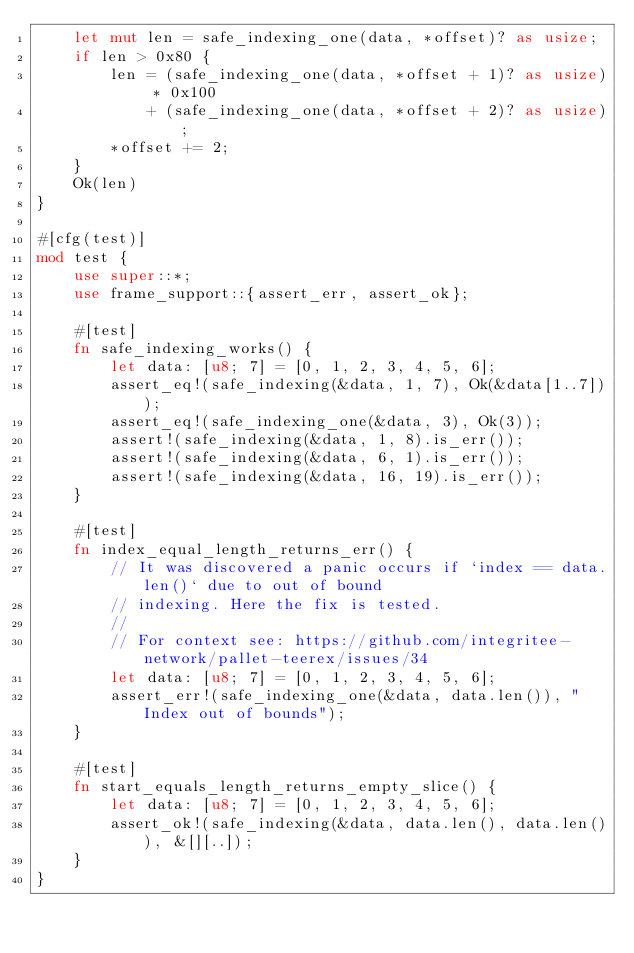<code> <loc_0><loc_0><loc_500><loc_500><_Rust_>    let mut len = safe_indexing_one(data, *offset)? as usize;
    if len > 0x80 {
        len = (safe_indexing_one(data, *offset + 1)? as usize) * 0x100
            + (safe_indexing_one(data, *offset + 2)? as usize);
        *offset += 2;
    }
    Ok(len)
}

#[cfg(test)]
mod test {
    use super::*;
    use frame_support::{assert_err, assert_ok};

    #[test]
    fn safe_indexing_works() {
        let data: [u8; 7] = [0, 1, 2, 3, 4, 5, 6];
        assert_eq!(safe_indexing(&data, 1, 7), Ok(&data[1..7]));
        assert_eq!(safe_indexing_one(&data, 3), Ok(3));
        assert!(safe_indexing(&data, 1, 8).is_err());
        assert!(safe_indexing(&data, 6, 1).is_err());
        assert!(safe_indexing(&data, 16, 19).is_err());
    }

    #[test]
    fn index_equal_length_returns_err() {
        // It was discovered a panic occurs if `index == data.len()` due to out of bound
        // indexing. Here the fix is tested.
        //
        // For context see: https://github.com/integritee-network/pallet-teerex/issues/34
        let data: [u8; 7] = [0, 1, 2, 3, 4, 5, 6];
        assert_err!(safe_indexing_one(&data, data.len()), "Index out of bounds");
    }

    #[test]
    fn start_equals_length_returns_empty_slice() {
        let data: [u8; 7] = [0, 1, 2, 3, 4, 5, 6];
        assert_ok!(safe_indexing(&data, data.len(), data.len()), &[][..]);
    }
}
</code> 